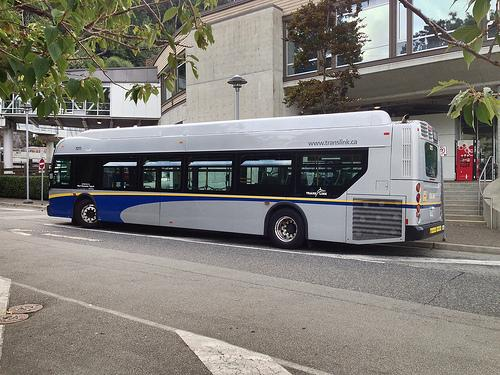Can you see any traffic signs in this image? If so, describe them briefly. There is a red and white do not enter wrong way sign, a stop sign on the corner, and two other do not enter signs. What are the two largest objects in the image, and what are their dimensions? A white and blue city bus with a width of 455 and a height of 455, and an asphalt city street with a width of 489 and a height of 489. What actions are taking place in the scene portrayed? A bus is driving down a not-so-busy city street, and there is a do not enter sign on a metal post nearby. Describe any unusual or unique characteristics of the bus featured in the image. The bus features a white roof, a yellow stripe, is run by Translink, and displays a website address at www.translink.ca. Which object is the farthest to the right in the image, and what are its details? Stairs in front of a building are the farthest to the right, with a width of 62 and a height of 62. What types of transportation are visible in this image? A blue and white city bus and a manhole cover on a city street are shown, along with a few street signs. Please provide a brief description of the main object in the center of the picture. A white and blue bus with a yellow stripe on it, run by Translink, is on a city street, featuring a white roof and a website address at www.translink.ca. Describe any streetlights or lamp posts visible in the scene. There are two city streetlights on metal poles, one with a width of 48 and a height of 48, and another with a width of 22 and a height of 22. Additionally, there is a white lamp post with a width of 32 and a height of 32. Describe the dominant colors and objects of the image. The image features a blue and white bus, a red vending machine, and a few street signs in red and white. Pick out three objects in this picture that haven't been mentioned yet and describe them. A building beside the road, a tall tree in the background, and cement steps with a metal handrail leading up to a building. 